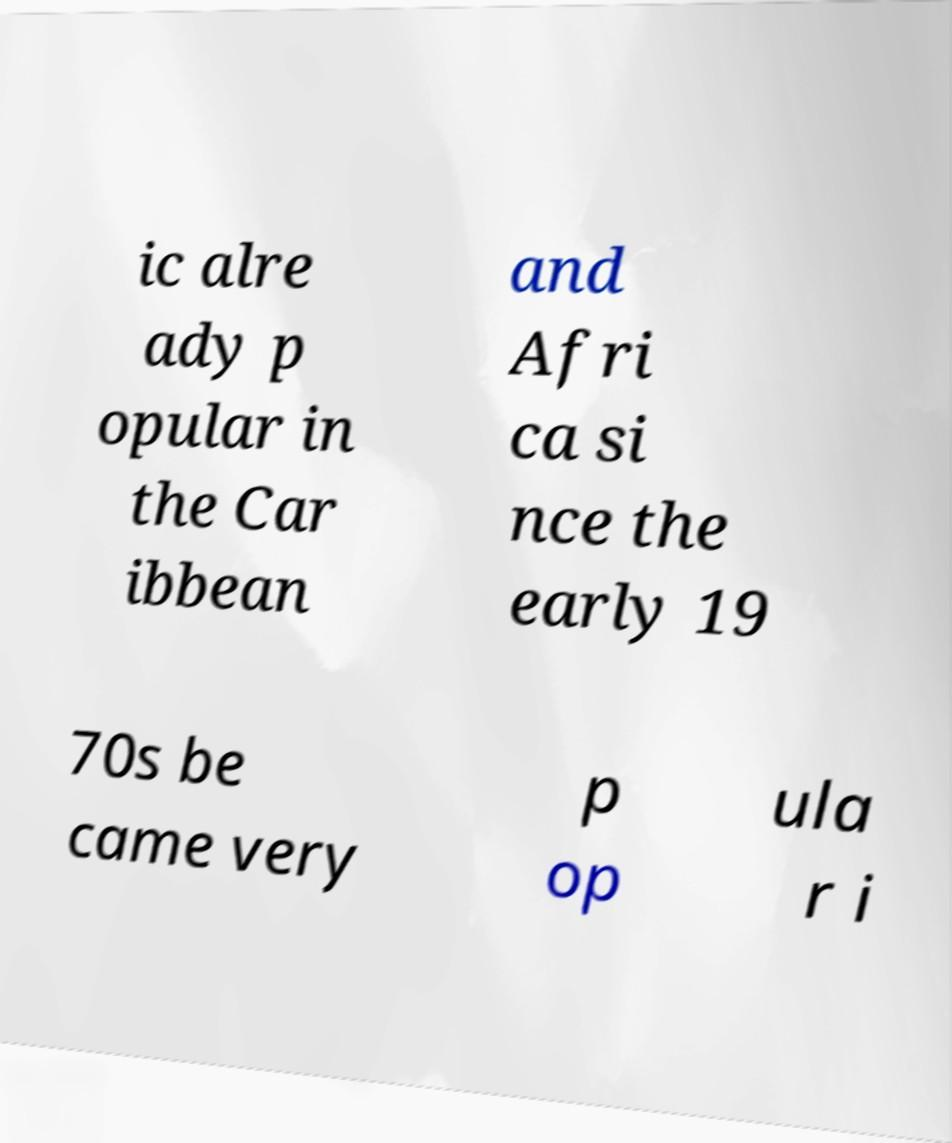There's text embedded in this image that I need extracted. Can you transcribe it verbatim? ic alre ady p opular in the Car ibbean and Afri ca si nce the early 19 70s be came very p op ula r i 